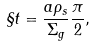<formula> <loc_0><loc_0><loc_500><loc_500>\S t = \frac { a \rho _ { s } } { \Sigma _ { g } } \frac { \pi } { 2 } ,</formula> 